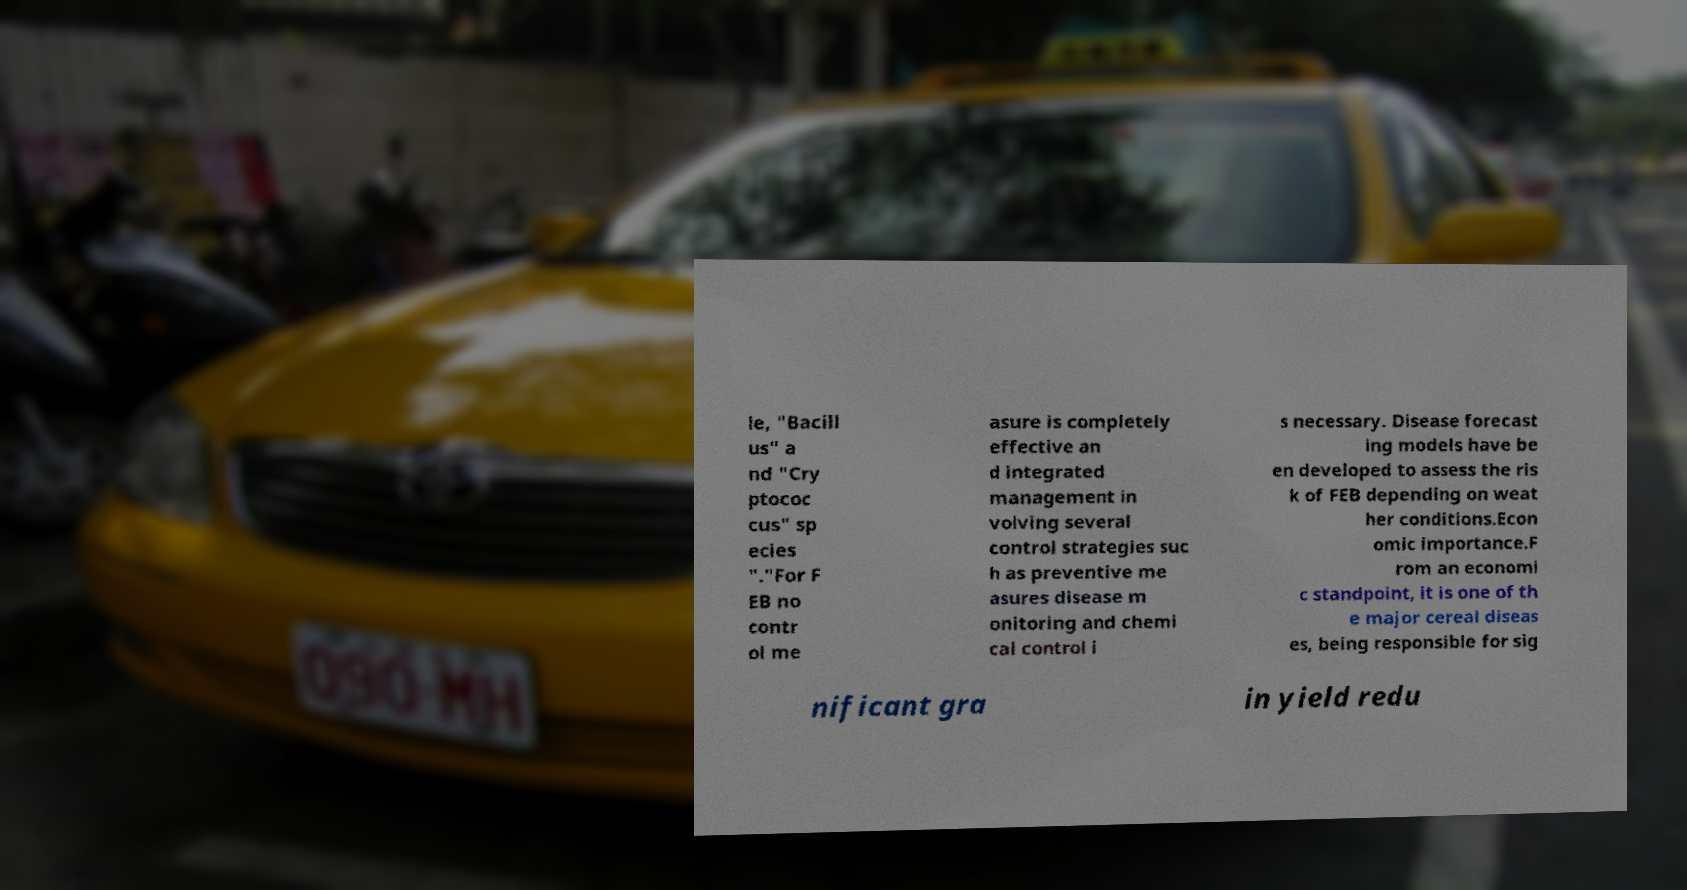I need the written content from this picture converted into text. Can you do that? le, "Bacill us" a nd "Cry ptococ cus" sp ecies "."For F EB no contr ol me asure is completely effective an d integrated management in volving several control strategies suc h as preventive me asures disease m onitoring and chemi cal control i s necessary. Disease forecast ing models have be en developed to assess the ris k of FEB depending on weat her conditions.Econ omic importance.F rom an economi c standpoint, it is one of th e major cereal diseas es, being responsible for sig nificant gra in yield redu 